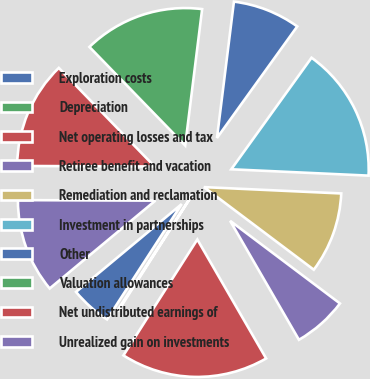Convert chart to OTSL. <chart><loc_0><loc_0><loc_500><loc_500><pie_chart><fcel>Exploration costs<fcel>Depreciation<fcel>Net operating losses and tax<fcel>Retiree benefit and vacation<fcel>Remediation and reclamation<fcel>Investment in partnerships<fcel>Other<fcel>Valuation allowances<fcel>Net undistributed earnings of<fcel>Unrealized gain on investments<nl><fcel>4.82%<fcel>0.11%<fcel>17.38%<fcel>6.39%<fcel>9.53%<fcel>15.81%<fcel>7.96%<fcel>14.24%<fcel>12.67%<fcel>11.1%<nl></chart> 